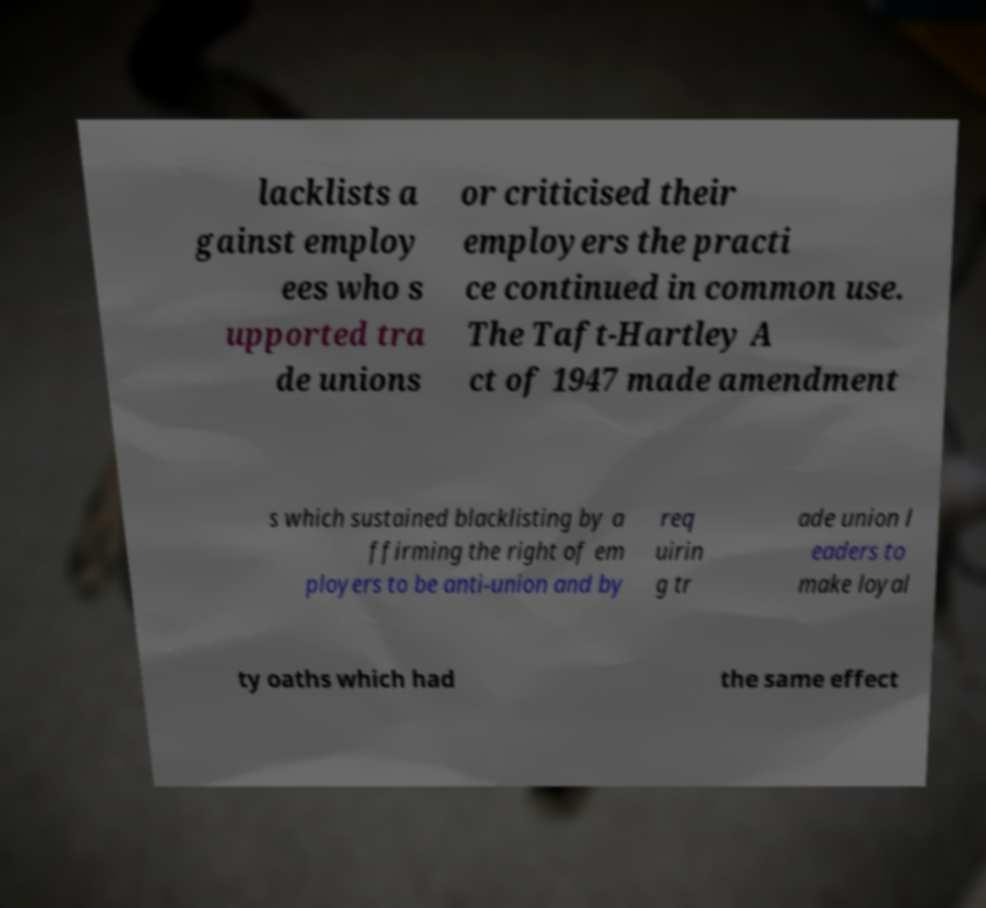Can you read and provide the text displayed in the image?This photo seems to have some interesting text. Can you extract and type it out for me? lacklists a gainst employ ees who s upported tra de unions or criticised their employers the practi ce continued in common use. The Taft-Hartley A ct of 1947 made amendment s which sustained blacklisting by a ffirming the right of em ployers to be anti-union and by req uirin g tr ade union l eaders to make loyal ty oaths which had the same effect 